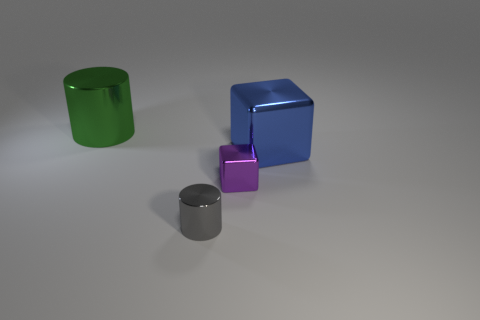Are there fewer blue things than tiny gray blocks?
Your answer should be very brief. No. Are there any tiny cylinders in front of the shiny thing that is on the left side of the gray cylinder?
Your answer should be compact. Yes. There is a tiny purple object that is made of the same material as the large block; what is its shape?
Ensure brevity in your answer.  Cube. What material is the other thing that is the same shape as the green metal thing?
Offer a terse response. Metal. How many other objects are the same size as the gray metallic object?
Keep it short and to the point. 1. Does the large object that is left of the large cube have the same shape as the small purple metallic object?
Make the answer very short. No. The small shiny thing that is in front of the tiny purple object has what shape?
Your response must be concise. Cylinder. Is there a gray thing that has the same material as the tiny purple object?
Give a very brief answer. Yes. What is the size of the gray shiny object?
Your answer should be compact. Small. Are there any large blue metallic cubes behind the cylinder in front of the block right of the small purple metallic object?
Your response must be concise. Yes. 